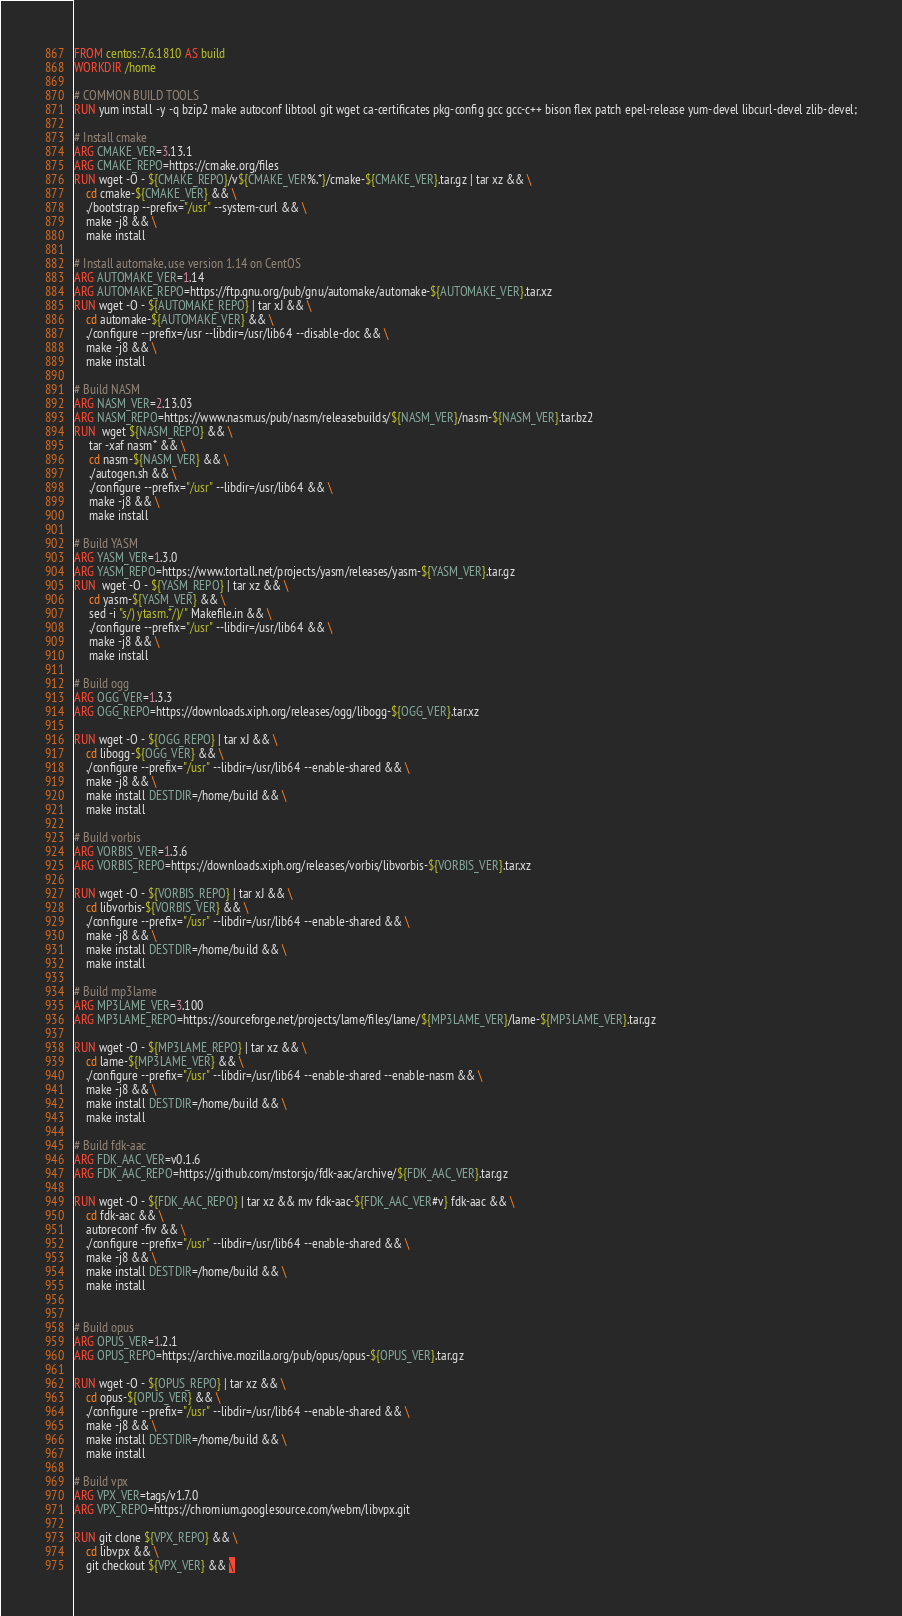<code> <loc_0><loc_0><loc_500><loc_500><_Dockerfile_>
FROM centos:7.6.1810 AS build
WORKDIR /home

# COMMON BUILD TOOLS
RUN yum install -y -q bzip2 make autoconf libtool git wget ca-certificates pkg-config gcc gcc-c++ bison flex patch epel-release yum-devel libcurl-devel zlib-devel;

# Install cmake
ARG CMAKE_VER=3.13.1
ARG CMAKE_REPO=https://cmake.org/files
RUN wget -O - ${CMAKE_REPO}/v${CMAKE_VER%.*}/cmake-${CMAKE_VER}.tar.gz | tar xz && \
    cd cmake-${CMAKE_VER} && \
    ./bootstrap --prefix="/usr" --system-curl && \
    make -j8 && \
    make install

# Install automake, use version 1.14 on CentOS
ARG AUTOMAKE_VER=1.14
ARG AUTOMAKE_REPO=https://ftp.gnu.org/pub/gnu/automake/automake-${AUTOMAKE_VER}.tar.xz
RUN wget -O - ${AUTOMAKE_REPO} | tar xJ && \
    cd automake-${AUTOMAKE_VER} && \
    ./configure --prefix=/usr --libdir=/usr/lib64 --disable-doc && \ 
    make -j8 && \
    make install

# Build NASM
ARG NASM_VER=2.13.03
ARG NASM_REPO=https://www.nasm.us/pub/nasm/releasebuilds/${NASM_VER}/nasm-${NASM_VER}.tar.bz2
RUN  wget ${NASM_REPO} && \
     tar -xaf nasm* && \
     cd nasm-${NASM_VER} && \
     ./autogen.sh && \
     ./configure --prefix="/usr" --libdir=/usr/lib64 && \
     make -j8 && \
     make install

# Build YASM
ARG YASM_VER=1.3.0
ARG YASM_REPO=https://www.tortall.net/projects/yasm/releases/yasm-${YASM_VER}.tar.gz
RUN  wget -O - ${YASM_REPO} | tar xz && \
     cd yasm-${YASM_VER} && \
     sed -i "s/) ytasm.*/)/" Makefile.in && \
     ./configure --prefix="/usr" --libdir=/usr/lib64 && \
     make -j8 && \
     make install

# Build ogg
ARG OGG_VER=1.3.3
ARG OGG_REPO=https://downloads.xiph.org/releases/ogg/libogg-${OGG_VER}.tar.xz

RUN wget -O - ${OGG_REPO} | tar xJ && \
    cd libogg-${OGG_VER} && \
    ./configure --prefix="/usr" --libdir=/usr/lib64 --enable-shared && \
    make -j8 && \
    make install DESTDIR=/home/build && \
    make install

# Build vorbis
ARG VORBIS_VER=1.3.6
ARG VORBIS_REPO=https://downloads.xiph.org/releases/vorbis/libvorbis-${VORBIS_VER}.tar.xz

RUN wget -O - ${VORBIS_REPO} | tar xJ && \
    cd libvorbis-${VORBIS_VER} && \
    ./configure --prefix="/usr" --libdir=/usr/lib64 --enable-shared && \
    make -j8 && \
    make install DESTDIR=/home/build && \
    make install

# Build mp3lame
ARG MP3LAME_VER=3.100
ARG MP3LAME_REPO=https://sourceforge.net/projects/lame/files/lame/${MP3LAME_VER}/lame-${MP3LAME_VER}.tar.gz

RUN wget -O - ${MP3LAME_REPO} | tar xz && \
    cd lame-${MP3LAME_VER} && \
    ./configure --prefix="/usr" --libdir=/usr/lib64 --enable-shared --enable-nasm && \
    make -j8 && \
    make install DESTDIR=/home/build && \
    make install

# Build fdk-aac
ARG FDK_AAC_VER=v0.1.6
ARG FDK_AAC_REPO=https://github.com/mstorsjo/fdk-aac/archive/${FDK_AAC_VER}.tar.gz

RUN wget -O - ${FDK_AAC_REPO} | tar xz && mv fdk-aac-${FDK_AAC_VER#v} fdk-aac && \
    cd fdk-aac && \
    autoreconf -fiv && \
    ./configure --prefix="/usr" --libdir=/usr/lib64 --enable-shared && \
    make -j8 && \
    make install DESTDIR=/home/build && \
    make install


# Build opus
ARG OPUS_VER=1.2.1
ARG OPUS_REPO=https://archive.mozilla.org/pub/opus/opus-${OPUS_VER}.tar.gz

RUN wget -O - ${OPUS_REPO} | tar xz && \
    cd opus-${OPUS_VER} && \
    ./configure --prefix="/usr" --libdir=/usr/lib64 --enable-shared && \
    make -j8 && \
    make install DESTDIR=/home/build && \
    make install

# Build vpx
ARG VPX_VER=tags/v1.7.0
ARG VPX_REPO=https://chromium.googlesource.com/webm/libvpx.git

RUN git clone ${VPX_REPO} && \
    cd libvpx && \
    git checkout ${VPX_VER} && \</code> 